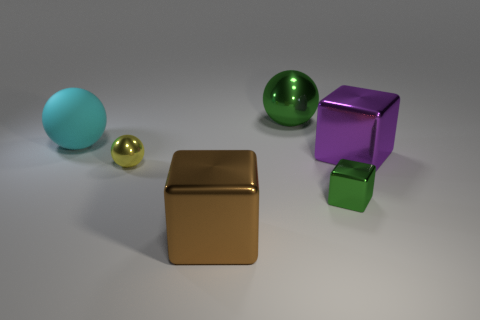What color is the rubber object that is the same shape as the yellow shiny thing?
Ensure brevity in your answer.  Cyan. There is a metallic block that is behind the yellow metal object; is its size the same as the green sphere?
Ensure brevity in your answer.  Yes. What shape is the big metal object that is the same color as the small block?
Your answer should be very brief. Sphere. What number of objects are the same material as the brown cube?
Offer a very short reply. 4. There is a big thing that is to the left of the metal sphere that is in front of the big shiny block right of the large brown block; what is it made of?
Offer a very short reply. Rubber. What color is the big thing in front of the green metallic thing on the right side of the green shiny ball?
Your answer should be very brief. Brown. The matte ball that is the same size as the purple block is what color?
Keep it short and to the point. Cyan. What number of big things are either red balls or cyan spheres?
Provide a short and direct response. 1. Is the number of brown cubes that are right of the green ball greater than the number of small cubes in front of the large brown object?
Provide a short and direct response. No. What size is the sphere that is the same color as the tiny metal cube?
Your response must be concise. Large. 